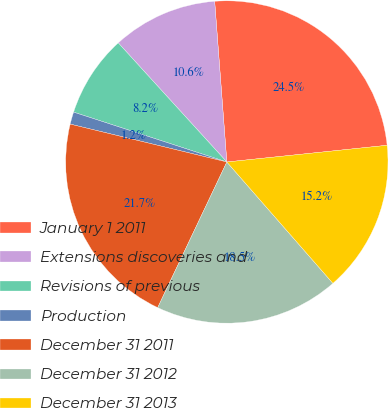Convert chart. <chart><loc_0><loc_0><loc_500><loc_500><pie_chart><fcel>January 1 2011<fcel>Extensions discoveries and<fcel>Revisions of previous<fcel>Production<fcel>December 31 2011<fcel>December 31 2012<fcel>December 31 2013<nl><fcel>24.55%<fcel>10.56%<fcel>8.23%<fcel>1.23%<fcel>21.72%<fcel>18.49%<fcel>15.22%<nl></chart> 